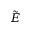Convert formula to latex. <formula><loc_0><loc_0><loc_500><loc_500>\tilde { E }</formula> 